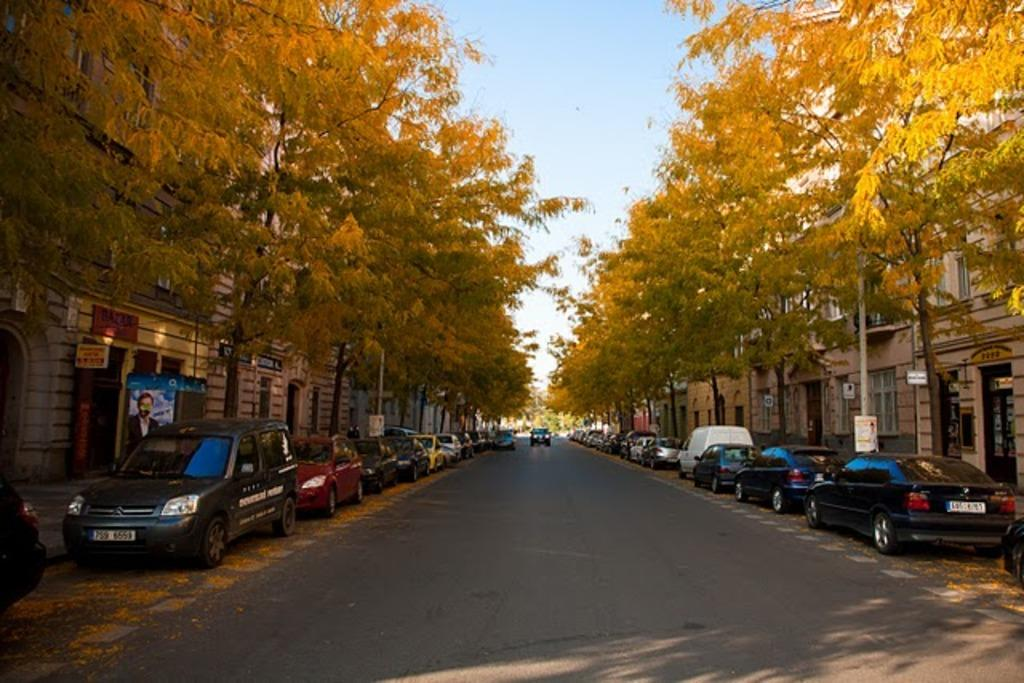What is the main feature of the image? There is a road in the image. What can be seen on both sides of the road? Cars are parked on either side of the road. What type of vegetation is present in the image? There are trees in the image. What type of structures are visible in the image? There are buildings in the image. What is visible at the top of the image? The sky is visible at the top of the image. How many pickles are hanging from the trees in the image? There are no pickles present in the image; it features a road, parked cars, trees, buildings, and the sky. What color are the oranges on the buildings in the image? There are no oranges present on the buildings in the image; it only features trees, buildings, and the sky. 